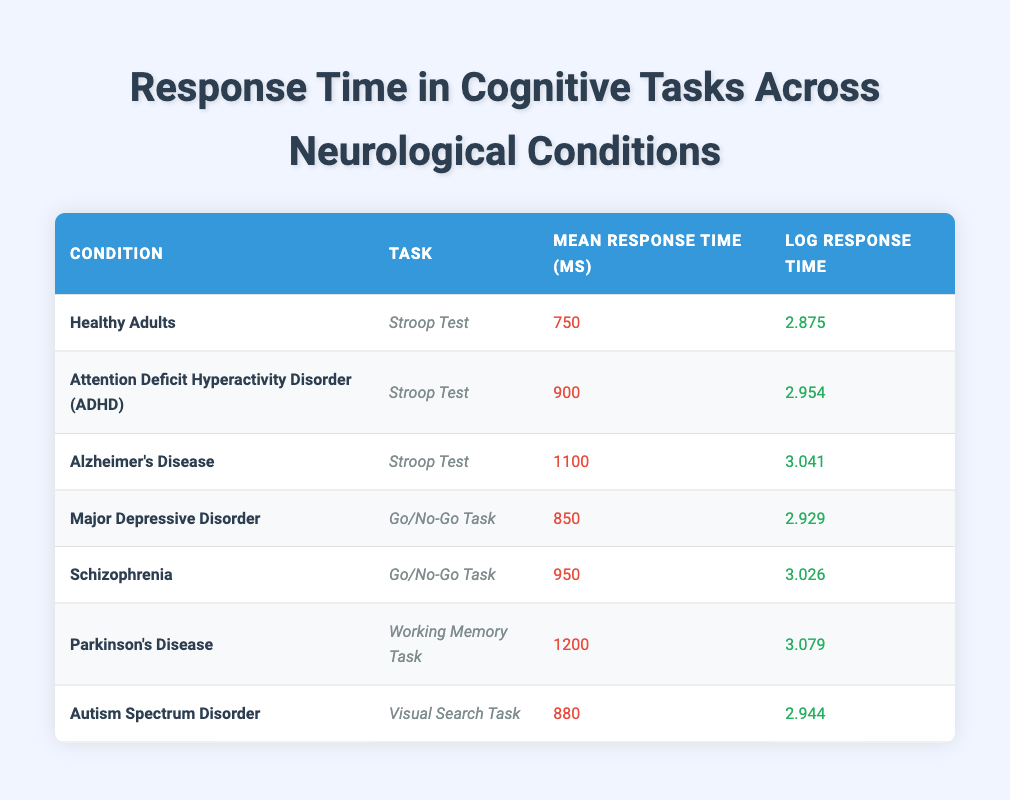What is the mean response time for Healthy Adults in the Stroop Test? The table lists the mean response time for Healthy Adults in the Stroop Test as 750 milliseconds.
Answer: 750 milliseconds Which condition has the highest mean response time and what is that time? By looking at the mean response times across all conditions, Parkinson's Disease has the highest mean response time of 1200 milliseconds.
Answer: 1200 milliseconds What is the difference in log response time between Alzheimer's Disease and ADHD in the Stroop Test? The log response time for Alzheimer's Disease is 3.041 and for ADHD it is 2.954. The difference is calculated as 3.041 - 2.954 = 0.087.
Answer: 0.087 Is the mean response time for Schizophrenia in the Go/No-Go Task greater than for Major Depressive Disorder? The mean response time for Schizophrenia is 950 milliseconds, while for Major Depressive Disorder it is 850 milliseconds. Since 950 is greater than 850, the statement is true.
Answer: Yes What is the average mean response time across all tasks listed in the table? To find the average mean response time, sum the mean response times: 750 + 900 + 1100 + 850 + 950 + 1200 + 880 = 5630. There are 7 conditions, so the average is 5630 / 7 = 804.29 milliseconds.
Answer: 804.29 milliseconds Which condition has the lowest log response time and what is that value? The table shows that Healthy Adults have the lowest log response time at 2.875.
Answer: 2.875 What tasks are associated with both Major Depressive Disorder and Schizophrenia, and how do their mean response times compare? Major Depressive Disorder uses the Go/No-Go Task, as does Schizophrenia. The mean response time for Major Depressive Disorder is 850 milliseconds while for Schizophrenia it is 950 milliseconds. Thus, Schizophrenia's response time is greater by 100 milliseconds.
Answer: Go/No-Go Task; Schizophrenia is higher by 100 milliseconds Are the mean response times for cognitive tasks in neuropsychiatric conditions generally higher than those for Healthy Adults? Mean response times for Healthy Adults is 750 milliseconds; ADHD is 900 milliseconds, Alzheimer's is 1100 milliseconds, Major Depressive Disorder is 850 milliseconds, Schizophrenia is 950 milliseconds, Parkinson's is 1200 milliseconds, and Autism Spectrum Disorder is 880 milliseconds. Since most neuropsychiatric conditions have higher response times than 750 ms, the statement is true.
Answer: Yes What is the ratio of the mean response time of Parkinson's Disease to that of Healthy Adults? The mean response time for Parkinson's Disease is 1200 milliseconds and for Healthy Adults it is 750 milliseconds. The ratio is calculated as 1200 / 750 = 1.6.
Answer: 1.6 